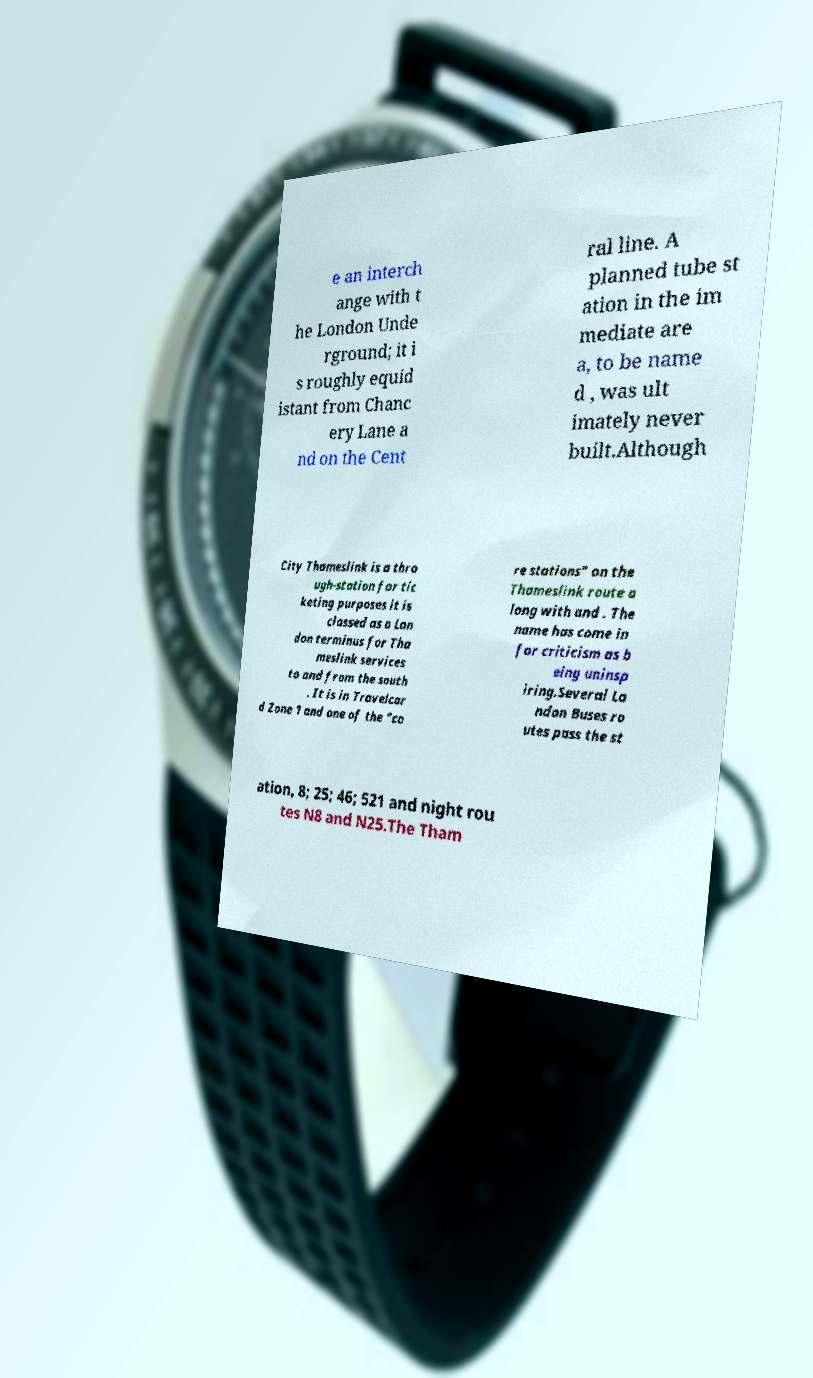Please identify and transcribe the text found in this image. e an interch ange with t he London Unde rground; it i s roughly equid istant from Chanc ery Lane a nd on the Cent ral line. A planned tube st ation in the im mediate are a, to be name d , was ult imately never built.Although City Thameslink is a thro ugh-station for tic keting purposes it is classed as a Lon don terminus for Tha meslink services to and from the south . It is in Travelcar d Zone 1 and one of the "co re stations" on the Thameslink route a long with and . The name has come in for criticism as b eing uninsp iring.Several Lo ndon Buses ro utes pass the st ation, 8; 25; 46; 521 and night rou tes N8 and N25.The Tham 